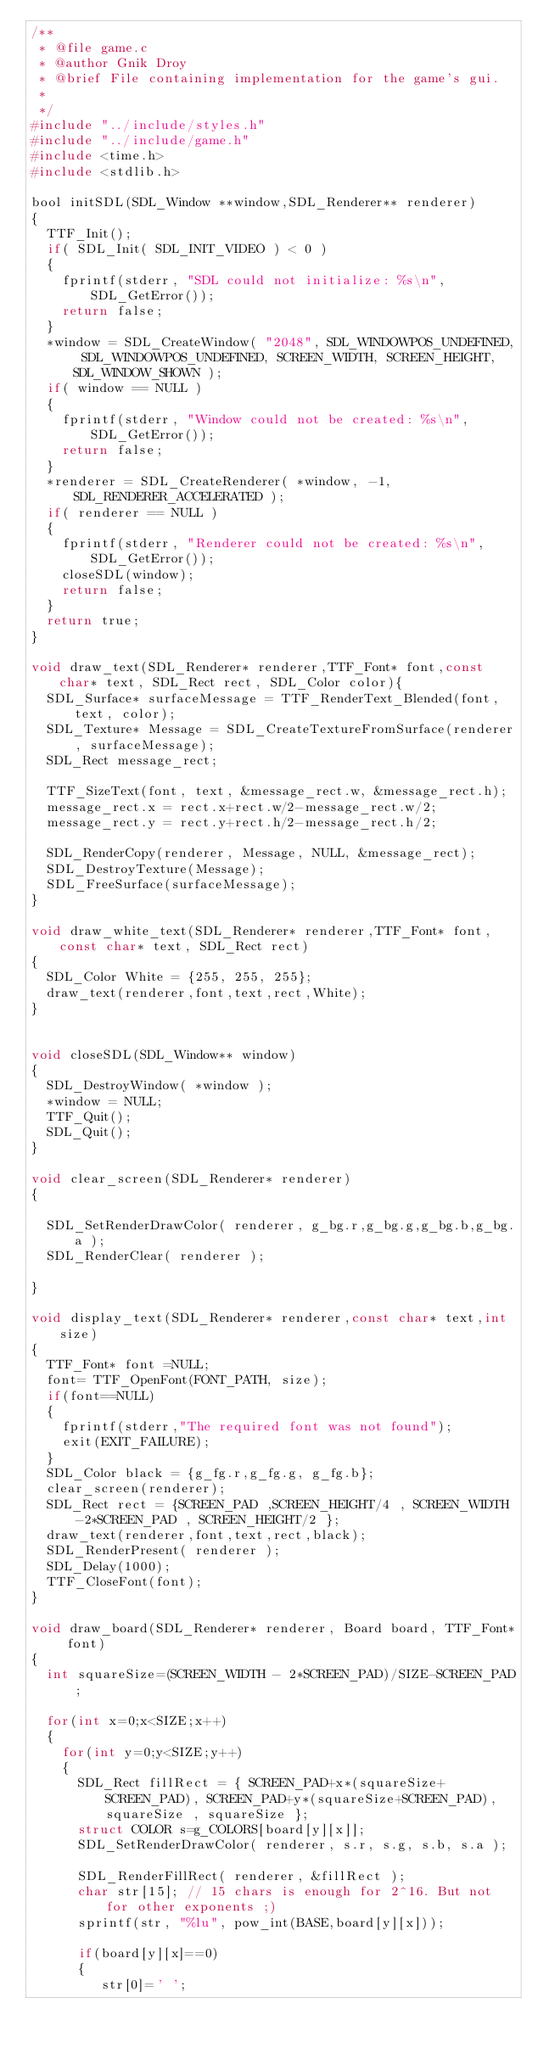Convert code to text. <code><loc_0><loc_0><loc_500><loc_500><_C_>/**
 * @file game.c
 * @author Gnik Droy
 * @brief File containing implementation for the game's gui.
 *
 */
#include "../include/styles.h"
#include "../include/game.h"
#include <time.h>
#include <stdlib.h>

bool initSDL(SDL_Window **window,SDL_Renderer** renderer)
{
	TTF_Init();
	if( SDL_Init( SDL_INIT_VIDEO ) < 0 )
	{
		fprintf(stderr, "SDL could not initialize: %s\n", SDL_GetError());
		return false;
	}
	*window = SDL_CreateWindow( "2048", SDL_WINDOWPOS_UNDEFINED, SDL_WINDOWPOS_UNDEFINED, SCREEN_WIDTH, SCREEN_HEIGHT, SDL_WINDOW_SHOWN );
	if( window == NULL )
	{
		fprintf(stderr, "Window could not be created: %s\n", SDL_GetError());
		return false;
	}
	*renderer = SDL_CreateRenderer( *window, -1, SDL_RENDERER_ACCELERATED );
	if( renderer == NULL )
	{
		fprintf(stderr, "Renderer could not be created: %s\n", SDL_GetError());
		closeSDL(window);
		return false;
	}
	return true;
}

void draw_text(SDL_Renderer* renderer,TTF_Font* font,const char* text, SDL_Rect rect, SDL_Color color){
	SDL_Surface* surfaceMessage = TTF_RenderText_Blended(font, text, color); 
	SDL_Texture* Message = SDL_CreateTextureFromSurface(renderer, surfaceMessage);
	SDL_Rect message_rect;
	
	TTF_SizeText(font, text, &message_rect.w, &message_rect.h);
	message_rect.x = rect.x+rect.w/2-message_rect.w/2;     
	message_rect.y = rect.y+rect.h/2-message_rect.h/2; 

	SDL_RenderCopy(renderer, Message, NULL, &message_rect); 
	SDL_DestroyTexture(Message);
	SDL_FreeSurface(surfaceMessage);
}

void draw_white_text(SDL_Renderer* renderer,TTF_Font* font,const char* text, SDL_Rect rect)
{
	SDL_Color White = {255, 255, 255};
	draw_text(renderer,font,text,rect,White);
}


void closeSDL(SDL_Window** window)
{
	SDL_DestroyWindow( *window );
	*window = NULL;
	TTF_Quit();
	SDL_Quit();
}

void clear_screen(SDL_Renderer* renderer)
{
	
	SDL_SetRenderDrawColor( renderer, g_bg.r,g_bg.g,g_bg.b,g_bg.a );
	SDL_RenderClear( renderer );

}

void display_text(SDL_Renderer* renderer,const char* text,int size)
{
	TTF_Font* font =NULL;
	font= TTF_OpenFont(FONT_PATH, size);
	if(font==NULL)
	{
		fprintf(stderr,"The required font was not found");
		exit(EXIT_FAILURE);
	}
	SDL_Color black = {g_fg.r,g_fg.g, g_fg.b};
	clear_screen(renderer);
	SDL_Rect rect = {SCREEN_PAD ,SCREEN_HEIGHT/4 , SCREEN_WIDTH-2*SCREEN_PAD , SCREEN_HEIGHT/2 };
	draw_text(renderer,font,text,rect,black);
	SDL_RenderPresent( renderer );
	SDL_Delay(1000);
	TTF_CloseFont(font);
}

void draw_board(SDL_Renderer* renderer, Board board, TTF_Font* font)
{
	int squareSize=(SCREEN_WIDTH - 2*SCREEN_PAD)/SIZE-SCREEN_PAD;

	for(int x=0;x<SIZE;x++)
	{
		for(int y=0;y<SIZE;y++)
		{
			SDL_Rect fillRect = { SCREEN_PAD+x*(squareSize+SCREEN_PAD), SCREEN_PAD+y*(squareSize+SCREEN_PAD), squareSize , squareSize };
			struct COLOR s=g_COLORS[board[y][x]];
			SDL_SetRenderDrawColor( renderer, s.r, s.g, s.b, s.a );		
			SDL_RenderFillRect( renderer, &fillRect );
			char str[15]; // 15 chars is enough for 2^16. But not for other exponents ;)
			sprintf(str, "%lu", pow_int(BASE,board[y][x]));

			if(board[y][x]==0)
			{
				 str[0]=' ';</code> 